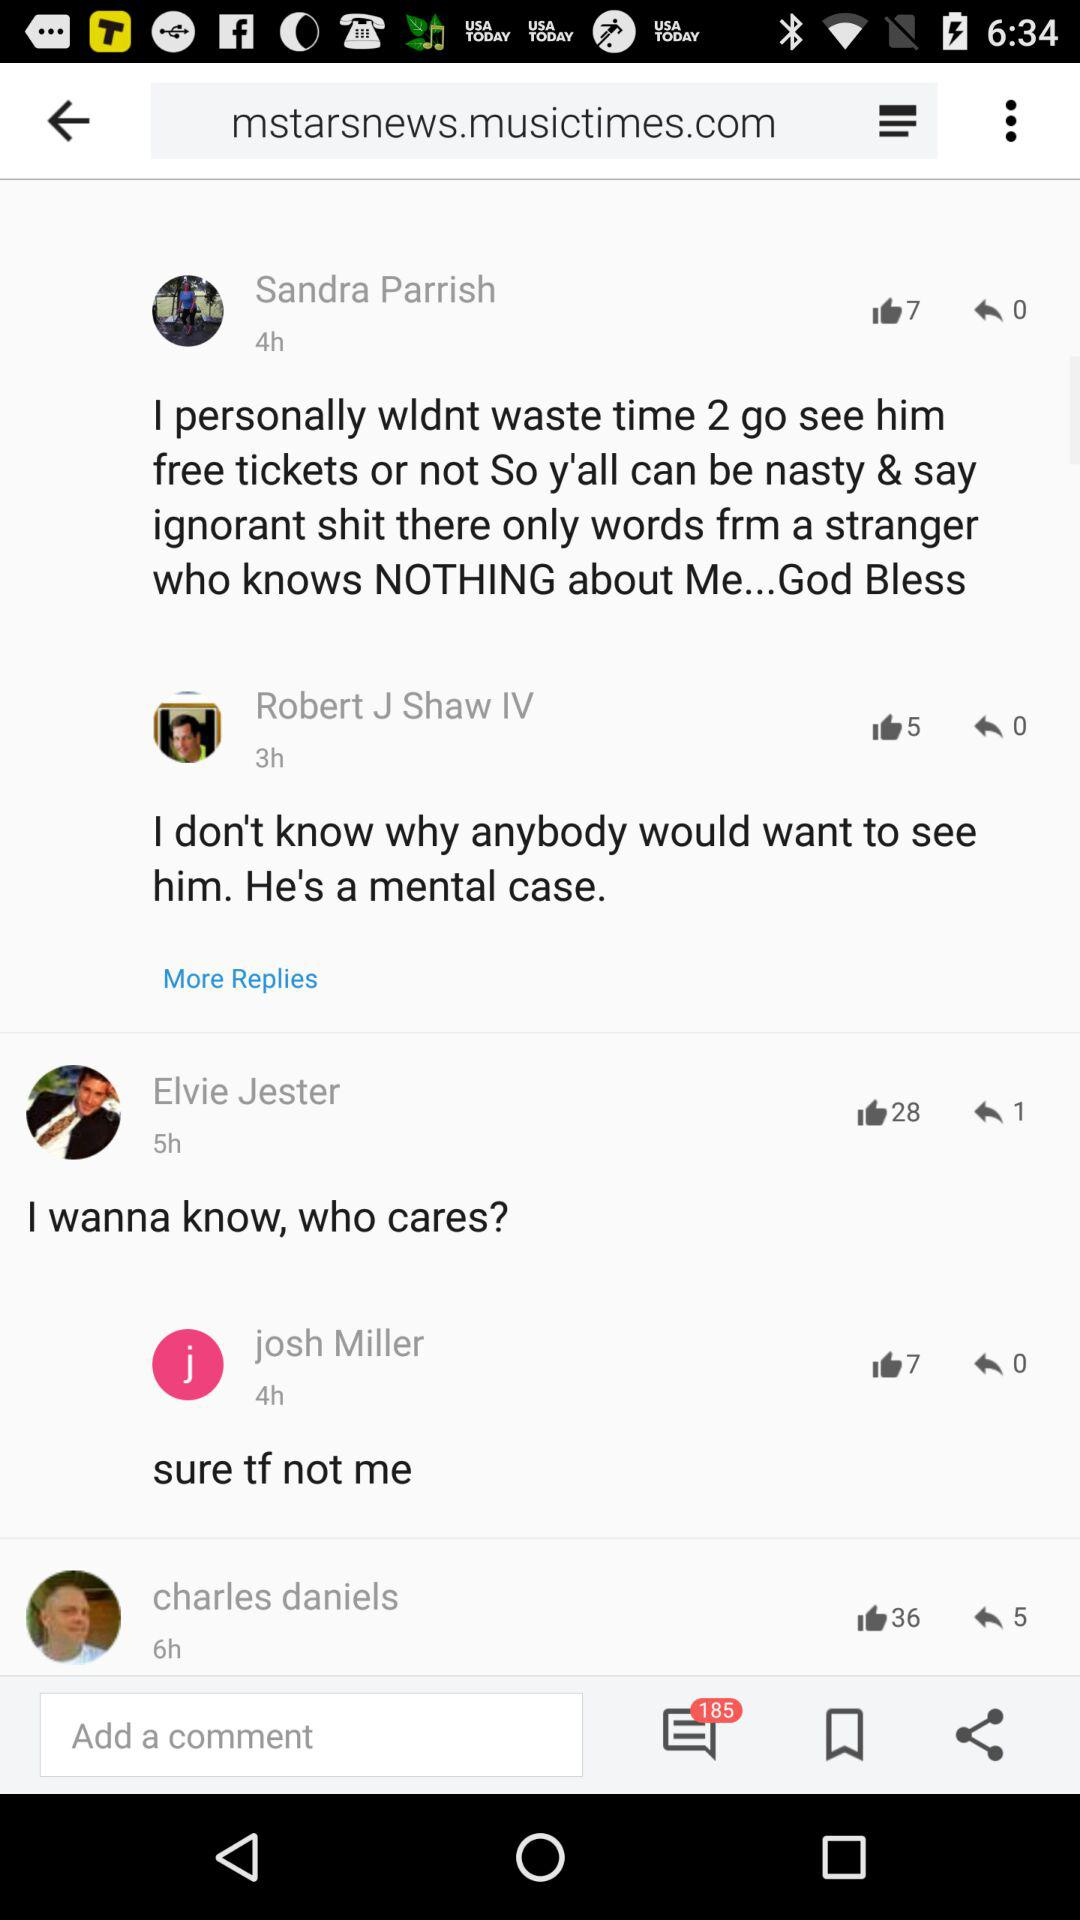What's the total number of comments? The total number of comments are 185. 